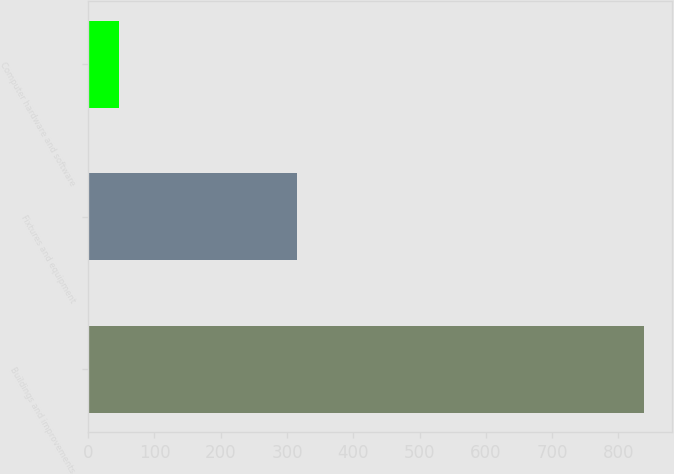<chart> <loc_0><loc_0><loc_500><loc_500><bar_chart><fcel>Buildings and improvements<fcel>Fixtures and equipment<fcel>Computer hardware and software<nl><fcel>839<fcel>315<fcel>47<nl></chart> 